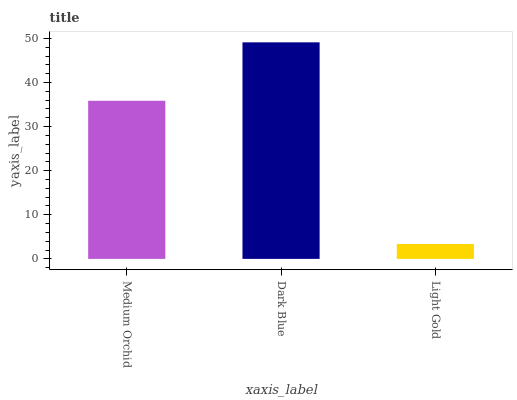Is Light Gold the minimum?
Answer yes or no. Yes. Is Dark Blue the maximum?
Answer yes or no. Yes. Is Dark Blue the minimum?
Answer yes or no. No. Is Light Gold the maximum?
Answer yes or no. No. Is Dark Blue greater than Light Gold?
Answer yes or no. Yes. Is Light Gold less than Dark Blue?
Answer yes or no. Yes. Is Light Gold greater than Dark Blue?
Answer yes or no. No. Is Dark Blue less than Light Gold?
Answer yes or no. No. Is Medium Orchid the high median?
Answer yes or no. Yes. Is Medium Orchid the low median?
Answer yes or no. Yes. Is Light Gold the high median?
Answer yes or no. No. Is Light Gold the low median?
Answer yes or no. No. 